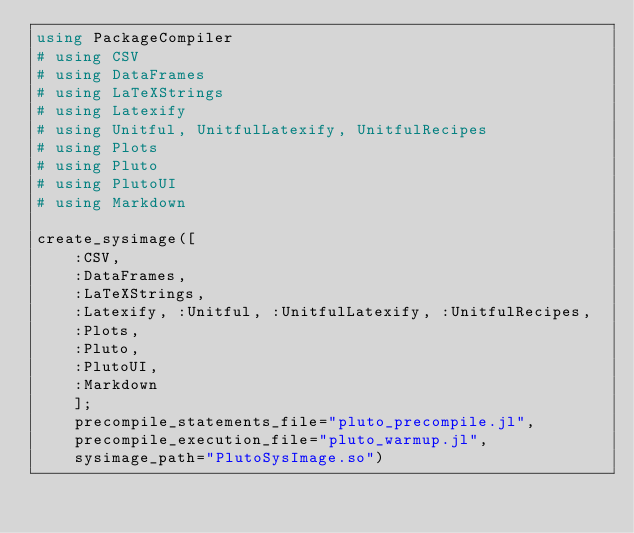Convert code to text. <code><loc_0><loc_0><loc_500><loc_500><_Julia_>using PackageCompiler
# using CSV
# using DataFrames
# using LaTeXStrings
# using Latexify
# using Unitful, UnitfulLatexify, UnitfulRecipes
# using Plots
# using Pluto
# using PlutoUI
# using Markdown

create_sysimage([
    :CSV, 
    :DataFrames,
    :LaTeXStrings,
    :Latexify, :Unitful, :UnitfulLatexify, :UnitfulRecipes,
    :Plots,
    :Pluto,
    :PlutoUI,
    :Markdown
    ];
    precompile_statements_file="pluto_precompile.jl",
    precompile_execution_file="pluto_warmup.jl",
    sysimage_path="PlutoSysImage.so")</code> 